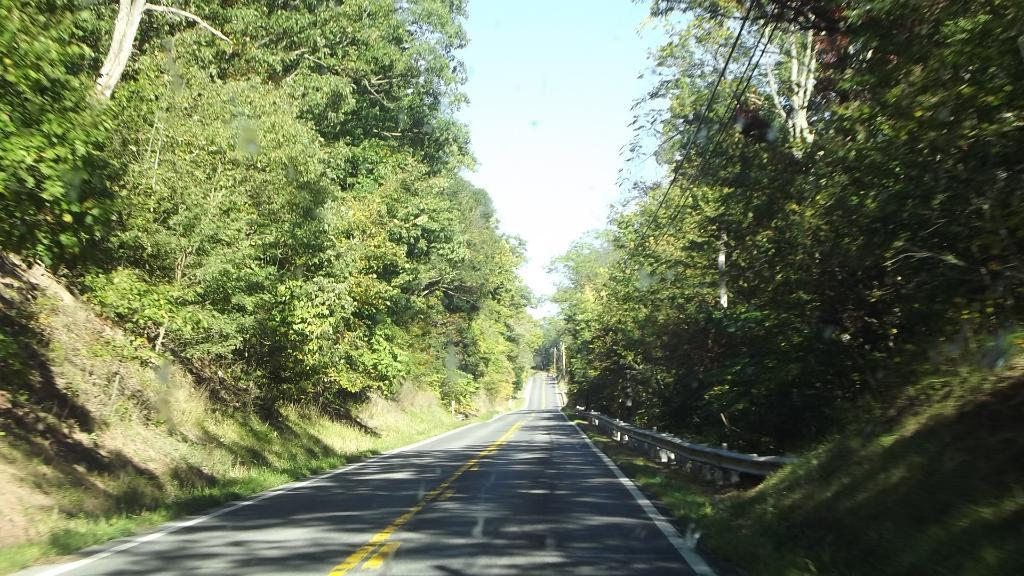What is the main feature in the middle of the image? There is a road in the middle of the image. What can be seen on both sides of the road? Trees are present on either side of the road. What is visible above the road in the image? The sky is visible above the road. How many bags can be seen hanging from the trees in the image? There are no bags present in the image; it only features a road, trees, and the sky. 